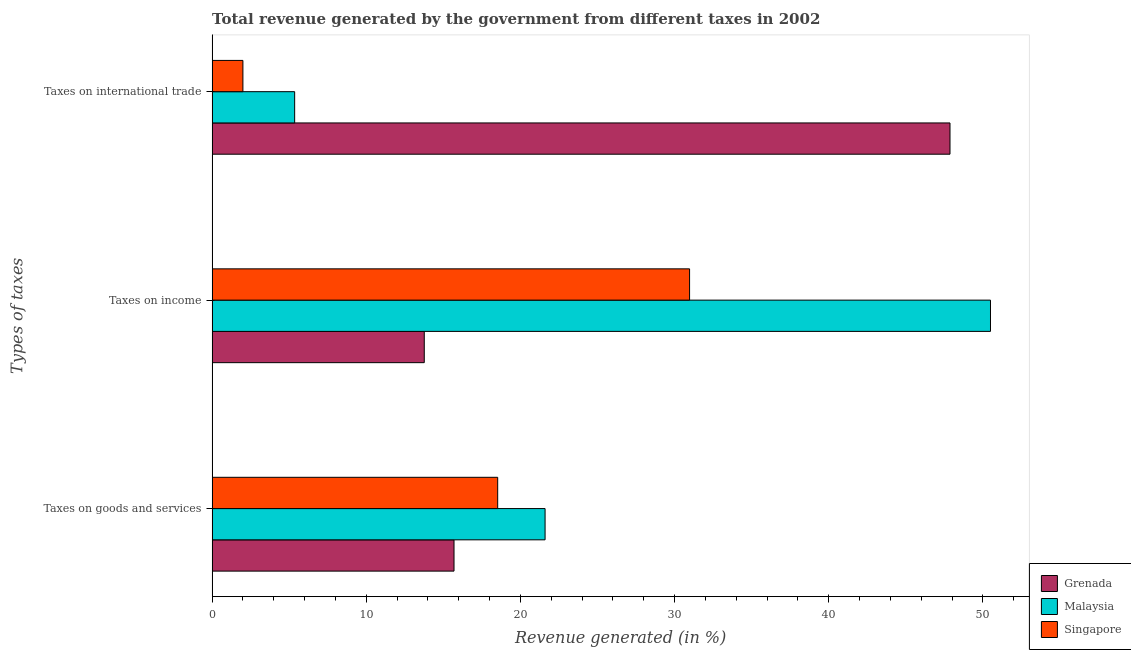How many different coloured bars are there?
Keep it short and to the point. 3. Are the number of bars per tick equal to the number of legend labels?
Keep it short and to the point. Yes. What is the label of the 2nd group of bars from the top?
Provide a short and direct response. Taxes on income. What is the percentage of revenue generated by taxes on income in Singapore?
Give a very brief answer. 30.97. Across all countries, what is the maximum percentage of revenue generated by tax on international trade?
Your answer should be very brief. 47.86. Across all countries, what is the minimum percentage of revenue generated by taxes on income?
Your response must be concise. 13.76. In which country was the percentage of revenue generated by tax on international trade maximum?
Ensure brevity in your answer.  Grenada. In which country was the percentage of revenue generated by taxes on goods and services minimum?
Make the answer very short. Grenada. What is the total percentage of revenue generated by taxes on goods and services in the graph?
Offer a terse response. 55.81. What is the difference between the percentage of revenue generated by taxes on goods and services in Singapore and that in Malaysia?
Your response must be concise. -3.07. What is the difference between the percentage of revenue generated by taxes on goods and services in Singapore and the percentage of revenue generated by tax on international trade in Grenada?
Make the answer very short. -29.34. What is the average percentage of revenue generated by tax on international trade per country?
Give a very brief answer. 18.41. What is the difference between the percentage of revenue generated by tax on international trade and percentage of revenue generated by taxes on goods and services in Malaysia?
Make the answer very short. -16.25. In how many countries, is the percentage of revenue generated by taxes on goods and services greater than 28 %?
Provide a short and direct response. 0. What is the ratio of the percentage of revenue generated by tax on international trade in Grenada to that in Malaysia?
Ensure brevity in your answer.  8.94. Is the difference between the percentage of revenue generated by taxes on goods and services in Grenada and Malaysia greater than the difference between the percentage of revenue generated by taxes on income in Grenada and Malaysia?
Provide a short and direct response. Yes. What is the difference between the highest and the second highest percentage of revenue generated by taxes on goods and services?
Your response must be concise. 3.07. What is the difference between the highest and the lowest percentage of revenue generated by tax on international trade?
Provide a short and direct response. 45.87. What does the 3rd bar from the top in Taxes on goods and services represents?
Make the answer very short. Grenada. What does the 2nd bar from the bottom in Taxes on income represents?
Your answer should be compact. Malaysia. Is it the case that in every country, the sum of the percentage of revenue generated by taxes on goods and services and percentage of revenue generated by taxes on income is greater than the percentage of revenue generated by tax on international trade?
Offer a terse response. No. Are all the bars in the graph horizontal?
Keep it short and to the point. Yes. How many countries are there in the graph?
Your response must be concise. 3. What is the difference between two consecutive major ticks on the X-axis?
Offer a very short reply. 10. Does the graph contain any zero values?
Your answer should be very brief. No. How many legend labels are there?
Your answer should be compact. 3. What is the title of the graph?
Your answer should be compact. Total revenue generated by the government from different taxes in 2002. What is the label or title of the X-axis?
Provide a short and direct response. Revenue generated (in %). What is the label or title of the Y-axis?
Your answer should be compact. Types of taxes. What is the Revenue generated (in %) of Grenada in Taxes on goods and services?
Offer a terse response. 15.69. What is the Revenue generated (in %) of Malaysia in Taxes on goods and services?
Offer a very short reply. 21.6. What is the Revenue generated (in %) of Singapore in Taxes on goods and services?
Keep it short and to the point. 18.52. What is the Revenue generated (in %) in Grenada in Taxes on income?
Provide a short and direct response. 13.76. What is the Revenue generated (in %) in Malaysia in Taxes on income?
Keep it short and to the point. 50.49. What is the Revenue generated (in %) of Singapore in Taxes on income?
Make the answer very short. 30.97. What is the Revenue generated (in %) of Grenada in Taxes on international trade?
Your response must be concise. 47.86. What is the Revenue generated (in %) in Malaysia in Taxes on international trade?
Your response must be concise. 5.35. What is the Revenue generated (in %) in Singapore in Taxes on international trade?
Your answer should be compact. 2. Across all Types of taxes, what is the maximum Revenue generated (in %) in Grenada?
Your response must be concise. 47.86. Across all Types of taxes, what is the maximum Revenue generated (in %) in Malaysia?
Your answer should be compact. 50.49. Across all Types of taxes, what is the maximum Revenue generated (in %) of Singapore?
Offer a terse response. 30.97. Across all Types of taxes, what is the minimum Revenue generated (in %) of Grenada?
Your response must be concise. 13.76. Across all Types of taxes, what is the minimum Revenue generated (in %) of Malaysia?
Offer a very short reply. 5.35. Across all Types of taxes, what is the minimum Revenue generated (in %) in Singapore?
Provide a short and direct response. 2. What is the total Revenue generated (in %) in Grenada in the graph?
Keep it short and to the point. 77.32. What is the total Revenue generated (in %) of Malaysia in the graph?
Provide a short and direct response. 77.44. What is the total Revenue generated (in %) of Singapore in the graph?
Your answer should be very brief. 51.49. What is the difference between the Revenue generated (in %) in Grenada in Taxes on goods and services and that in Taxes on income?
Your response must be concise. 1.93. What is the difference between the Revenue generated (in %) of Malaysia in Taxes on goods and services and that in Taxes on income?
Provide a short and direct response. -28.89. What is the difference between the Revenue generated (in %) of Singapore in Taxes on goods and services and that in Taxes on income?
Make the answer very short. -12.45. What is the difference between the Revenue generated (in %) of Grenada in Taxes on goods and services and that in Taxes on international trade?
Give a very brief answer. -32.17. What is the difference between the Revenue generated (in %) of Malaysia in Taxes on goods and services and that in Taxes on international trade?
Keep it short and to the point. 16.25. What is the difference between the Revenue generated (in %) in Singapore in Taxes on goods and services and that in Taxes on international trade?
Provide a short and direct response. 16.53. What is the difference between the Revenue generated (in %) in Grenada in Taxes on income and that in Taxes on international trade?
Your response must be concise. -34.1. What is the difference between the Revenue generated (in %) of Malaysia in Taxes on income and that in Taxes on international trade?
Offer a very short reply. 45.14. What is the difference between the Revenue generated (in %) of Singapore in Taxes on income and that in Taxes on international trade?
Make the answer very short. 28.97. What is the difference between the Revenue generated (in %) in Grenada in Taxes on goods and services and the Revenue generated (in %) in Malaysia in Taxes on income?
Give a very brief answer. -34.8. What is the difference between the Revenue generated (in %) of Grenada in Taxes on goods and services and the Revenue generated (in %) of Singapore in Taxes on income?
Keep it short and to the point. -15.28. What is the difference between the Revenue generated (in %) of Malaysia in Taxes on goods and services and the Revenue generated (in %) of Singapore in Taxes on income?
Your answer should be very brief. -9.37. What is the difference between the Revenue generated (in %) in Grenada in Taxes on goods and services and the Revenue generated (in %) in Malaysia in Taxes on international trade?
Ensure brevity in your answer.  10.34. What is the difference between the Revenue generated (in %) of Grenada in Taxes on goods and services and the Revenue generated (in %) of Singapore in Taxes on international trade?
Offer a very short reply. 13.69. What is the difference between the Revenue generated (in %) in Malaysia in Taxes on goods and services and the Revenue generated (in %) in Singapore in Taxes on international trade?
Your answer should be very brief. 19.6. What is the difference between the Revenue generated (in %) in Grenada in Taxes on income and the Revenue generated (in %) in Malaysia in Taxes on international trade?
Your answer should be very brief. 8.41. What is the difference between the Revenue generated (in %) of Grenada in Taxes on income and the Revenue generated (in %) of Singapore in Taxes on international trade?
Provide a succinct answer. 11.76. What is the difference between the Revenue generated (in %) of Malaysia in Taxes on income and the Revenue generated (in %) of Singapore in Taxes on international trade?
Provide a succinct answer. 48.49. What is the average Revenue generated (in %) of Grenada per Types of taxes?
Provide a succinct answer. 25.77. What is the average Revenue generated (in %) of Malaysia per Types of taxes?
Make the answer very short. 25.81. What is the average Revenue generated (in %) of Singapore per Types of taxes?
Offer a terse response. 17.16. What is the difference between the Revenue generated (in %) in Grenada and Revenue generated (in %) in Malaysia in Taxes on goods and services?
Offer a terse response. -5.91. What is the difference between the Revenue generated (in %) in Grenada and Revenue generated (in %) in Singapore in Taxes on goods and services?
Give a very brief answer. -2.83. What is the difference between the Revenue generated (in %) of Malaysia and Revenue generated (in %) of Singapore in Taxes on goods and services?
Your answer should be very brief. 3.07. What is the difference between the Revenue generated (in %) in Grenada and Revenue generated (in %) in Malaysia in Taxes on income?
Give a very brief answer. -36.73. What is the difference between the Revenue generated (in %) in Grenada and Revenue generated (in %) in Singapore in Taxes on income?
Your answer should be compact. -17.21. What is the difference between the Revenue generated (in %) in Malaysia and Revenue generated (in %) in Singapore in Taxes on income?
Make the answer very short. 19.52. What is the difference between the Revenue generated (in %) in Grenada and Revenue generated (in %) in Malaysia in Taxes on international trade?
Provide a short and direct response. 42.51. What is the difference between the Revenue generated (in %) of Grenada and Revenue generated (in %) of Singapore in Taxes on international trade?
Provide a succinct answer. 45.87. What is the difference between the Revenue generated (in %) in Malaysia and Revenue generated (in %) in Singapore in Taxes on international trade?
Ensure brevity in your answer.  3.36. What is the ratio of the Revenue generated (in %) of Grenada in Taxes on goods and services to that in Taxes on income?
Give a very brief answer. 1.14. What is the ratio of the Revenue generated (in %) of Malaysia in Taxes on goods and services to that in Taxes on income?
Your answer should be compact. 0.43. What is the ratio of the Revenue generated (in %) of Singapore in Taxes on goods and services to that in Taxes on income?
Offer a very short reply. 0.6. What is the ratio of the Revenue generated (in %) in Grenada in Taxes on goods and services to that in Taxes on international trade?
Keep it short and to the point. 0.33. What is the ratio of the Revenue generated (in %) in Malaysia in Taxes on goods and services to that in Taxes on international trade?
Make the answer very short. 4.03. What is the ratio of the Revenue generated (in %) of Singapore in Taxes on goods and services to that in Taxes on international trade?
Your answer should be very brief. 9.28. What is the ratio of the Revenue generated (in %) of Grenada in Taxes on income to that in Taxes on international trade?
Provide a short and direct response. 0.29. What is the ratio of the Revenue generated (in %) of Malaysia in Taxes on income to that in Taxes on international trade?
Keep it short and to the point. 9.43. What is the ratio of the Revenue generated (in %) of Singapore in Taxes on income to that in Taxes on international trade?
Your response must be concise. 15.51. What is the difference between the highest and the second highest Revenue generated (in %) of Grenada?
Ensure brevity in your answer.  32.17. What is the difference between the highest and the second highest Revenue generated (in %) in Malaysia?
Provide a short and direct response. 28.89. What is the difference between the highest and the second highest Revenue generated (in %) of Singapore?
Keep it short and to the point. 12.45. What is the difference between the highest and the lowest Revenue generated (in %) in Grenada?
Provide a short and direct response. 34.1. What is the difference between the highest and the lowest Revenue generated (in %) of Malaysia?
Your response must be concise. 45.14. What is the difference between the highest and the lowest Revenue generated (in %) in Singapore?
Ensure brevity in your answer.  28.97. 